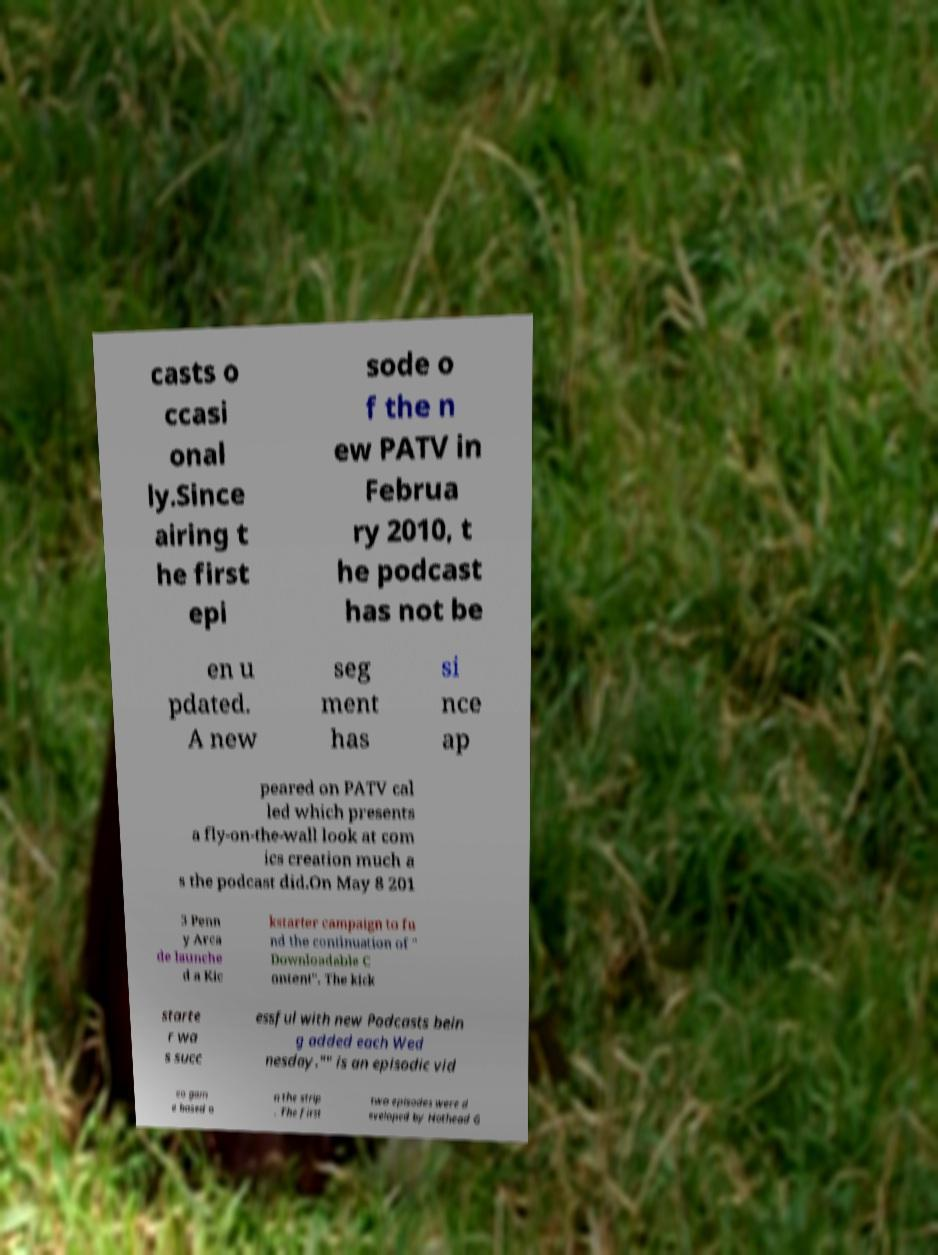I need the written content from this picture converted into text. Can you do that? casts o ccasi onal ly.Since airing t he first epi sode o f the n ew PATV in Februa ry 2010, t he podcast has not be en u pdated. A new seg ment has si nce ap peared on PATV cal led which presents a fly-on-the-wall look at com ics creation much a s the podcast did.On May 8 201 3 Penn y Arca de launche d a Kic kstarter campaign to fu nd the continuation of " Downloadable C ontent". The kick starte r wa s succ essful with new Podcasts bein g added each Wed nesday."" is an episodic vid eo gam e based o n the strip . The first two episodes were d eveloped by Hothead G 